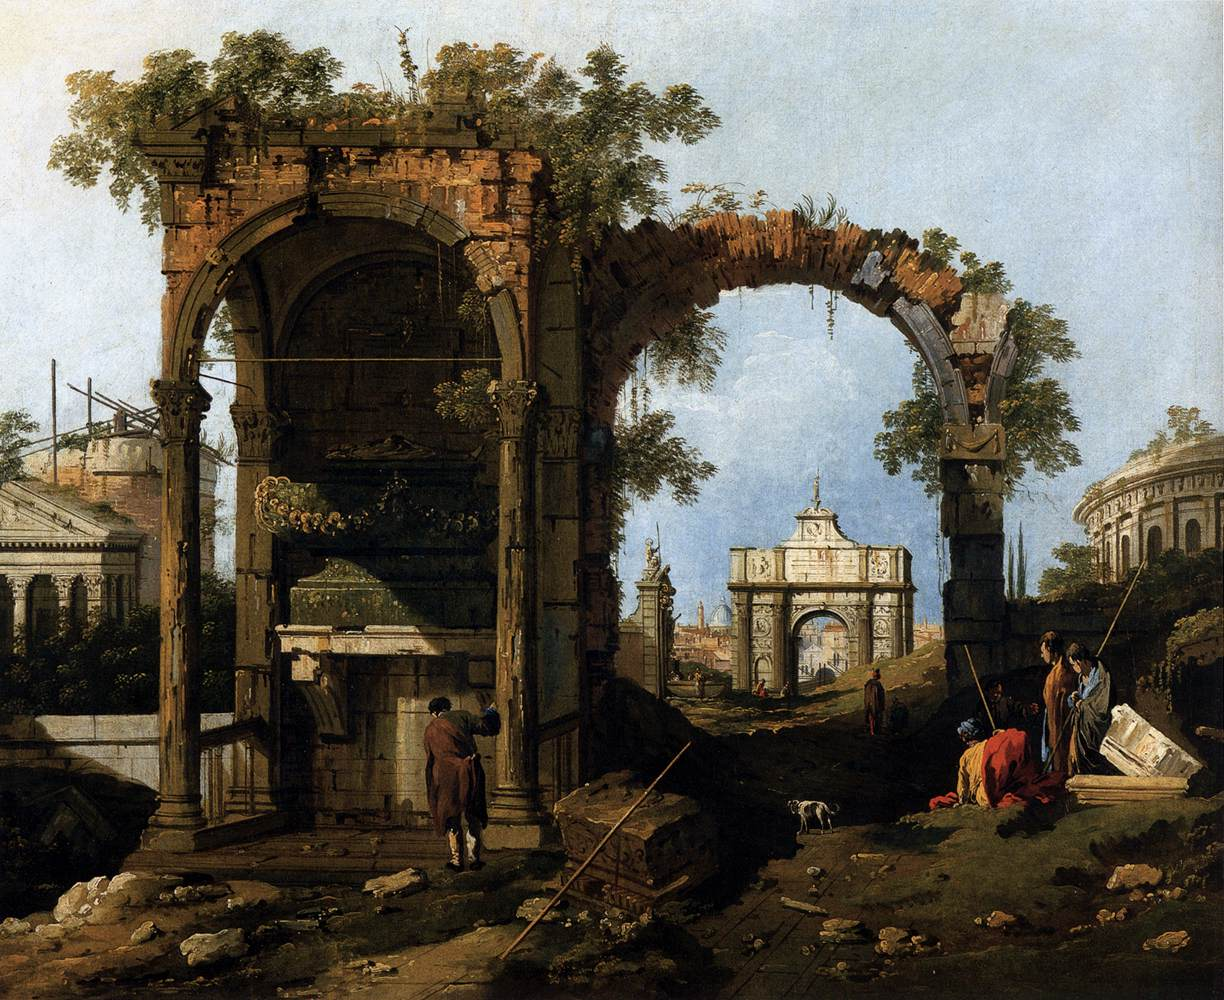Can you describe the mood and atmosphere of the painting? The mood and atmosphere of the painting are a blend of nostalgia and tranquility. The ruins evoke a longing for the past, suggesting the passage of time and the transience of human achievements. However, the lush foliage and clear blue sky infuse the scene with a sense of calm and resilience. The presence of figures brings life and activity, contrasting with the still and ancient ruins. Overall, the painting exudes a serene yet melancholic ambiance, characteristic of a reflective moment in time. 